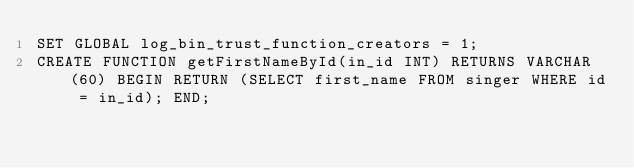Convert code to text. <code><loc_0><loc_0><loc_500><loc_500><_SQL_>SET GLOBAL log_bin_trust_function_creators = 1;
CREATE FUNCTION getFirstNameById(in_id INT) RETURNS VARCHAR(60) BEGIN RETURN (SELECT first_name FROM singer WHERE id = in_id); END; </code> 